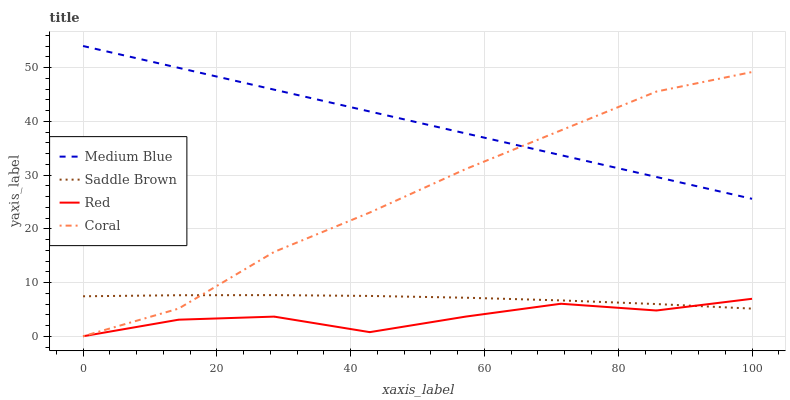Does Red have the minimum area under the curve?
Answer yes or no. Yes. Does Medium Blue have the maximum area under the curve?
Answer yes or no. Yes. Does Saddle Brown have the minimum area under the curve?
Answer yes or no. No. Does Saddle Brown have the maximum area under the curve?
Answer yes or no. No. Is Medium Blue the smoothest?
Answer yes or no. Yes. Is Red the roughest?
Answer yes or no. Yes. Is Saddle Brown the smoothest?
Answer yes or no. No. Is Saddle Brown the roughest?
Answer yes or no. No. Does Coral have the lowest value?
Answer yes or no. Yes. Does Saddle Brown have the lowest value?
Answer yes or no. No. Does Medium Blue have the highest value?
Answer yes or no. Yes. Does Saddle Brown have the highest value?
Answer yes or no. No. Is Red less than Medium Blue?
Answer yes or no. Yes. Is Medium Blue greater than Saddle Brown?
Answer yes or no. Yes. Does Coral intersect Red?
Answer yes or no. Yes. Is Coral less than Red?
Answer yes or no. No. Is Coral greater than Red?
Answer yes or no. No. Does Red intersect Medium Blue?
Answer yes or no. No. 